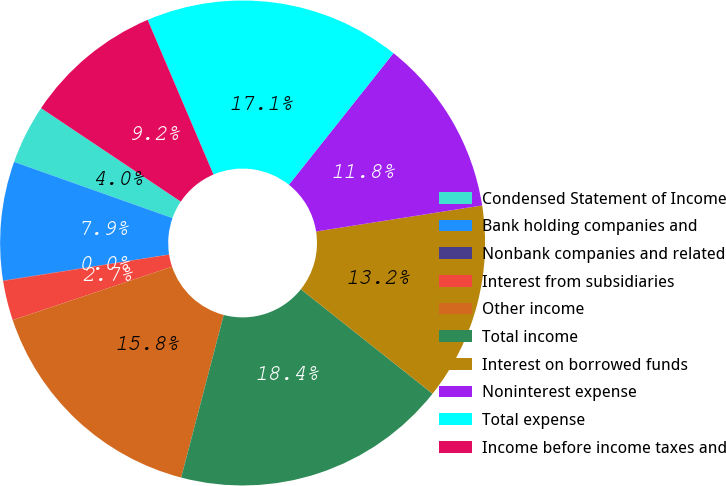Convert chart to OTSL. <chart><loc_0><loc_0><loc_500><loc_500><pie_chart><fcel>Condensed Statement of Income<fcel>Bank holding companies and<fcel>Nonbank companies and related<fcel>Interest from subsidiaries<fcel>Other income<fcel>Total income<fcel>Interest on borrowed funds<fcel>Noninterest expense<fcel>Total expense<fcel>Income before income taxes and<nl><fcel>3.96%<fcel>7.9%<fcel>0.03%<fcel>2.65%<fcel>15.77%<fcel>18.4%<fcel>13.15%<fcel>11.84%<fcel>17.09%<fcel>9.21%<nl></chart> 